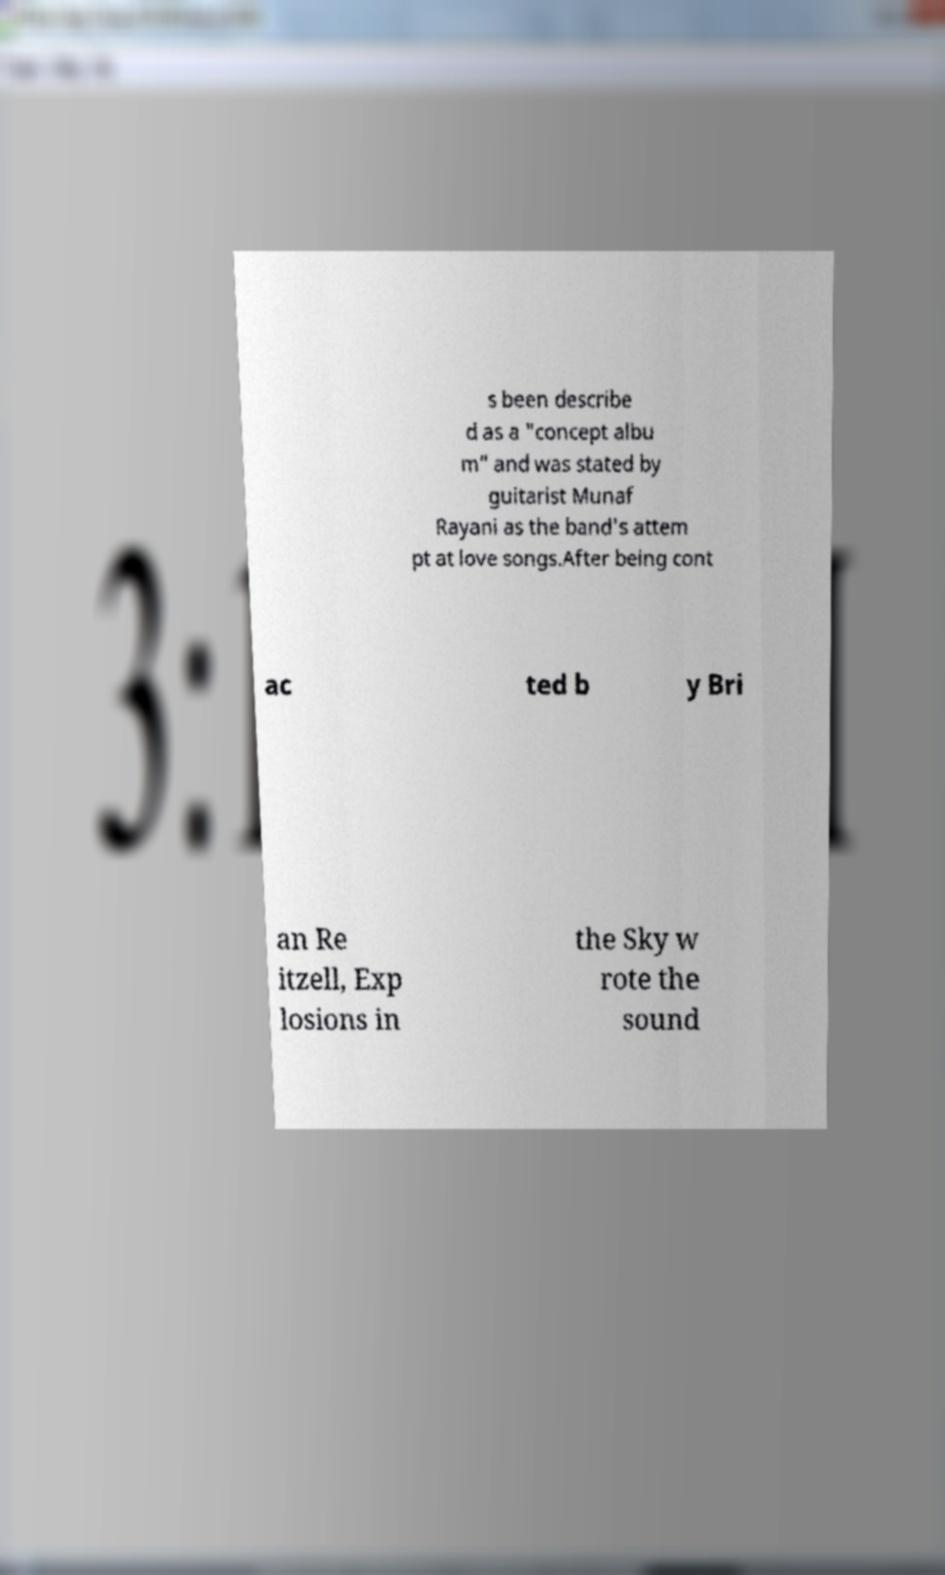Could you extract and type out the text from this image? s been describe d as a "concept albu m" and was stated by guitarist Munaf Rayani as the band's attem pt at love songs.After being cont ac ted b y Bri an Re itzell, Exp losions in the Sky w rote the sound 